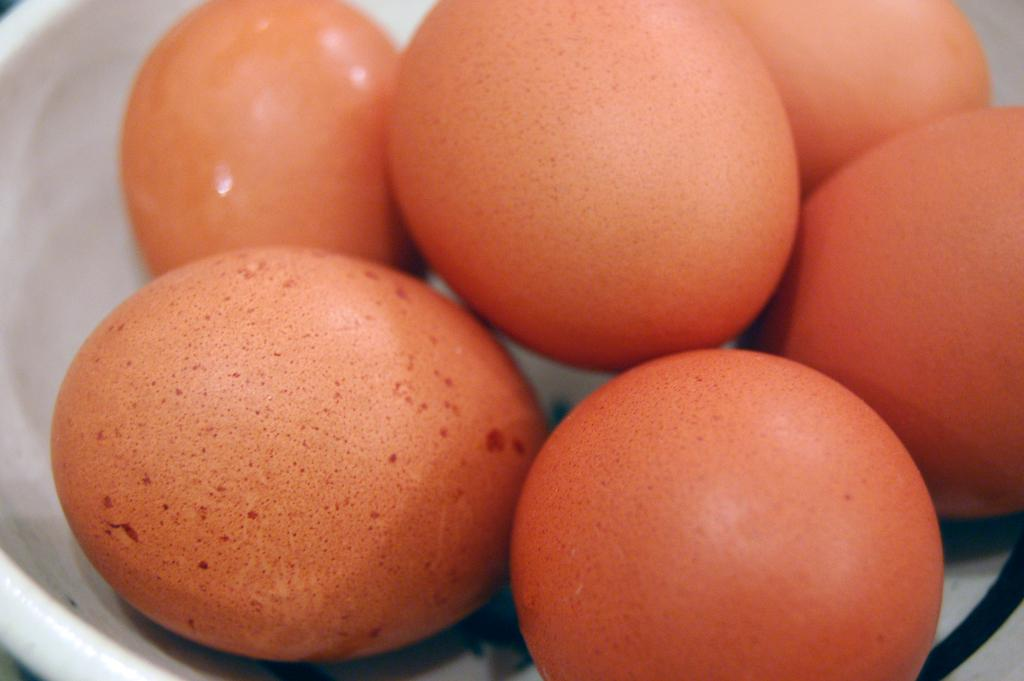What is the main subject of the picture? The main subject of the picture is eggs. Can you describe the color of the eggs? The eggs are in orange color. How are the eggs arranged or placed in the picture? The eggs are placed in a white bowl. What type of gun can be seen in the image? There is no gun present in the image; it features orange-colored eggs placed in a white bowl. 